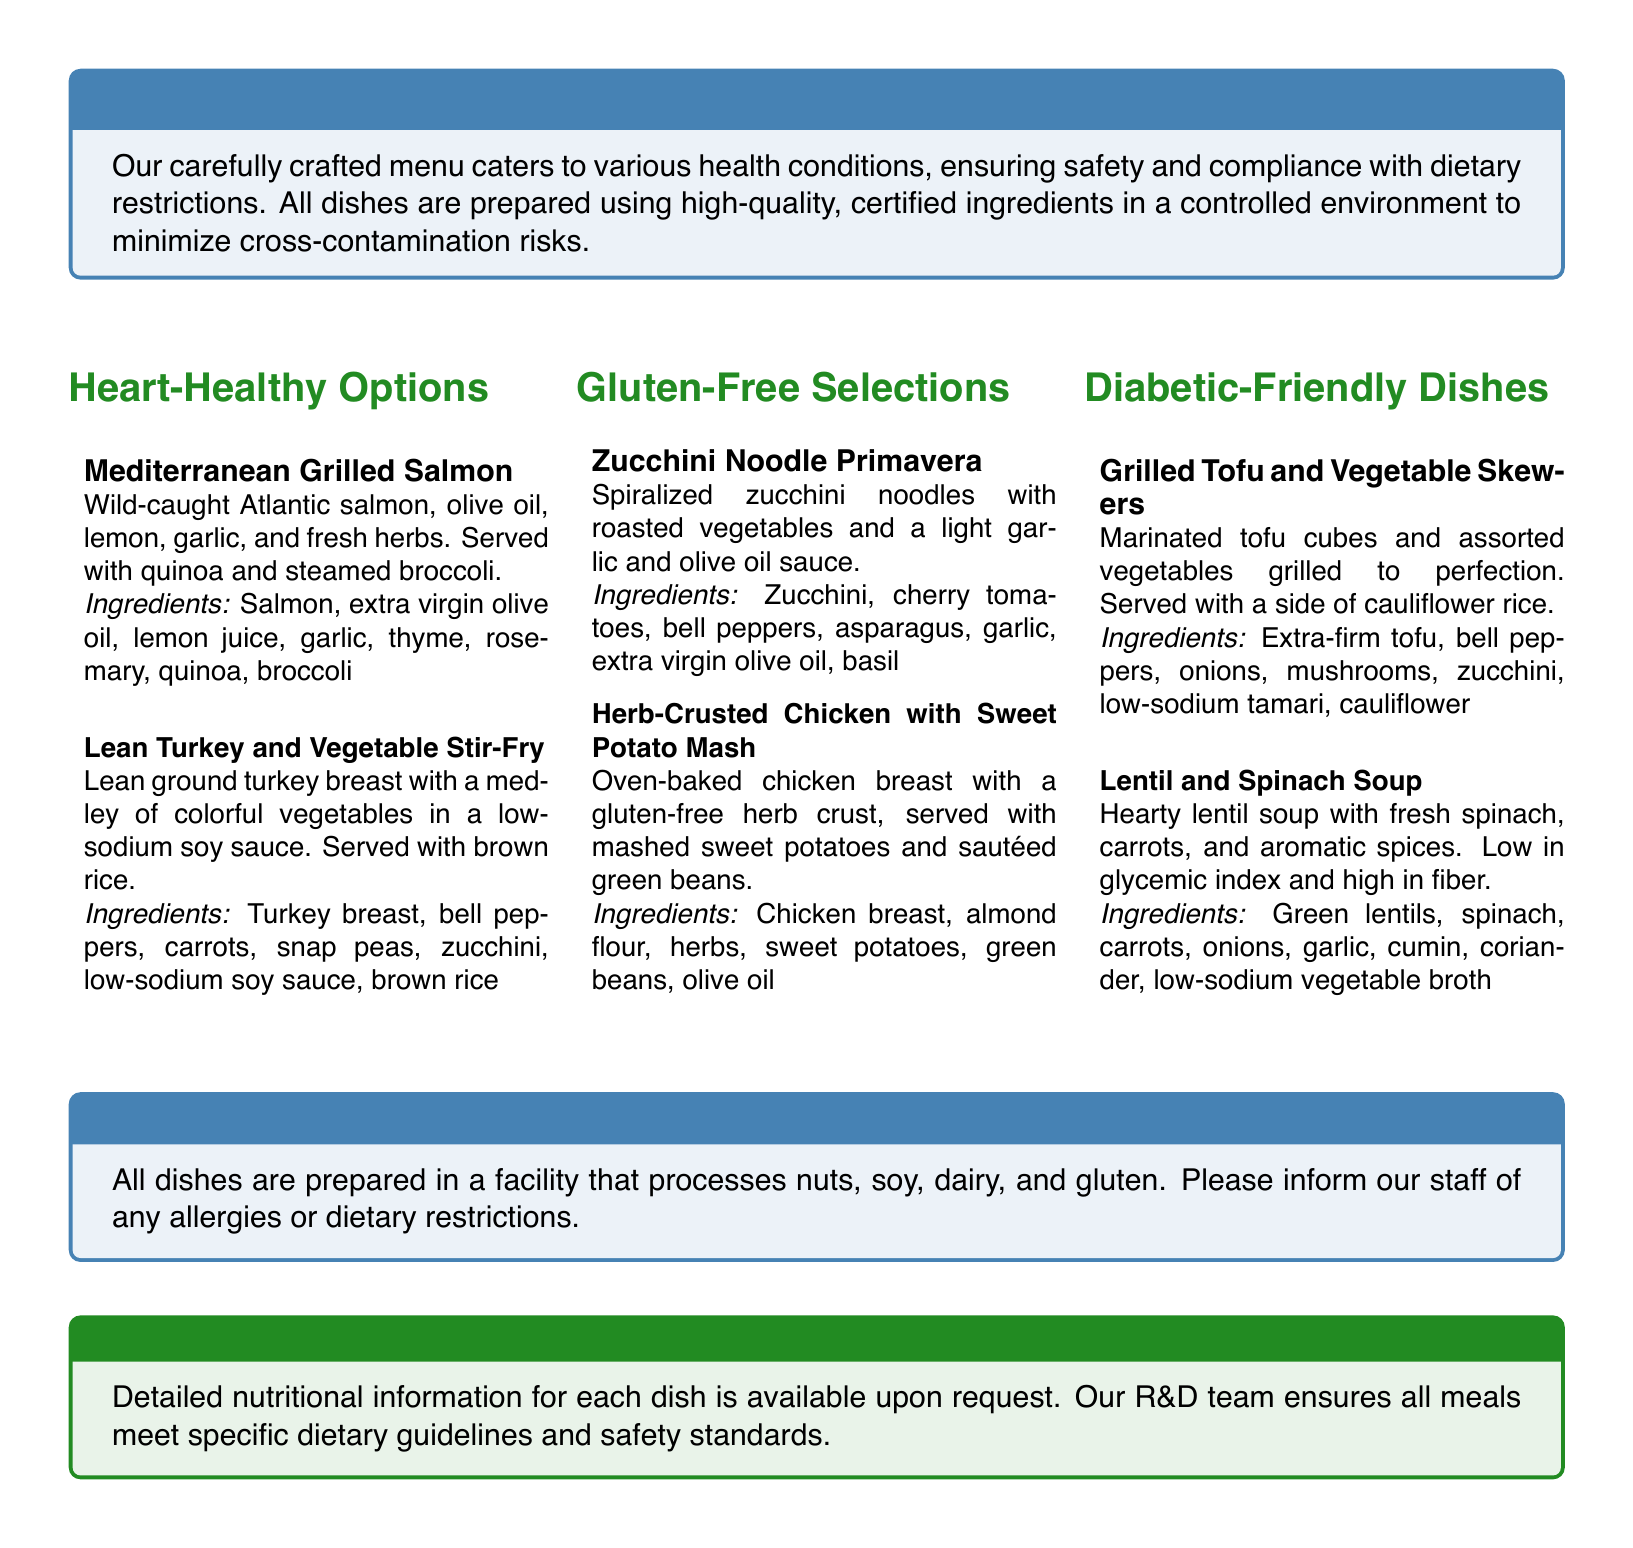What is the title of the menu? The title of the menu is at the top of the document, introducing the variety of offerings for health-conscious diners.
Answer: Wellness Cuisine: Specialized Diet Menu for Health-Conscious Diners Which dish is served with quinoa? This dish contains quinoa as a side, mentioned in the ingredient list.
Answer: Mediterranean Grilled Salmon What type of oil is used in the Mediterranean Grilled Salmon? The document specifies the type of oil used in this dish.
Answer: Extra virgin olive oil How many dishes are listed under Diabetic-Friendly Dishes? The number of dishes in the section is counted from the listed items.
Answer: Two What is used for the herb crust in the Herb-Crusted Chicken? The ingredient for the crust is noted in the preparation method section.
Answer: Almond flour Which dish is served with cauliflower rice? Cauliflower rice is mentioned as a side for this dish in the document.
Answer: Grilled Tofu and Vegetable Skewers Is there a mention of allergens in the menu? The menu contains information about allergens and dietary restrictions for safety.
Answer: Yes What type of broth is used in the Lentil and Spinach Soup? The document specifies the type of broth used in this dish.
Answer: Low-sodium vegetable broth What is available upon request regarding the dishes? This information is specified in the disclaimer section of the menu document.
Answer: Detailed nutritional information 